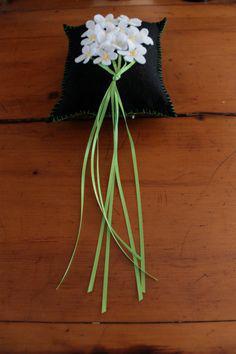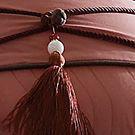The first image is the image on the left, the second image is the image on the right. Given the left and right images, does the statement "One room includes an orange sectional couch that forms a corner, in front of hanging orange drapes." hold true? Answer yes or no. No. 